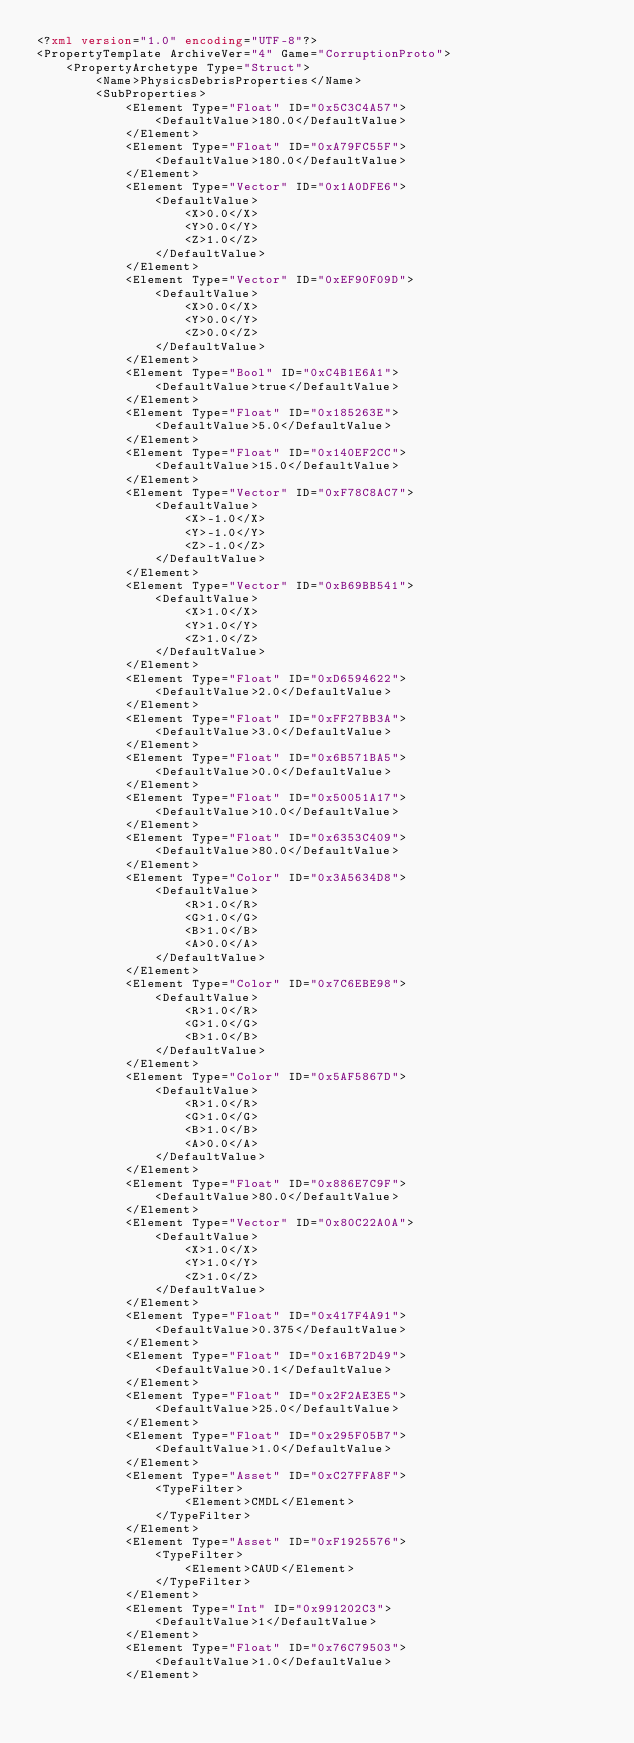Convert code to text. <code><loc_0><loc_0><loc_500><loc_500><_XML_><?xml version="1.0" encoding="UTF-8"?>
<PropertyTemplate ArchiveVer="4" Game="CorruptionProto">
    <PropertyArchetype Type="Struct">
        <Name>PhysicsDebrisProperties</Name>
        <SubProperties>
            <Element Type="Float" ID="0x5C3C4A57">
                <DefaultValue>180.0</DefaultValue>
            </Element>
            <Element Type="Float" ID="0xA79FC55F">
                <DefaultValue>180.0</DefaultValue>
            </Element>
            <Element Type="Vector" ID="0x1A0DFE6">
                <DefaultValue>
                    <X>0.0</X>
                    <Y>0.0</Y>
                    <Z>1.0</Z>
                </DefaultValue>
            </Element>
            <Element Type="Vector" ID="0xEF90F09D">
                <DefaultValue>
                    <X>0.0</X>
                    <Y>0.0</Y>
                    <Z>0.0</Z>
                </DefaultValue>
            </Element>
            <Element Type="Bool" ID="0xC4B1E6A1">
                <DefaultValue>true</DefaultValue>
            </Element>
            <Element Type="Float" ID="0x185263E">
                <DefaultValue>5.0</DefaultValue>
            </Element>
            <Element Type="Float" ID="0x140EF2CC">
                <DefaultValue>15.0</DefaultValue>
            </Element>
            <Element Type="Vector" ID="0xF78C8AC7">
                <DefaultValue>
                    <X>-1.0</X>
                    <Y>-1.0</Y>
                    <Z>-1.0</Z>
                </DefaultValue>
            </Element>
            <Element Type="Vector" ID="0xB69BB541">
                <DefaultValue>
                    <X>1.0</X>
                    <Y>1.0</Y>
                    <Z>1.0</Z>
                </DefaultValue>
            </Element>
            <Element Type="Float" ID="0xD6594622">
                <DefaultValue>2.0</DefaultValue>
            </Element>
            <Element Type="Float" ID="0xFF27BB3A">
                <DefaultValue>3.0</DefaultValue>
            </Element>
            <Element Type="Float" ID="0x6B571BA5">
                <DefaultValue>0.0</DefaultValue>
            </Element>
            <Element Type="Float" ID="0x50051A17">
                <DefaultValue>10.0</DefaultValue>
            </Element>
            <Element Type="Float" ID="0x6353C409">
                <DefaultValue>80.0</DefaultValue>
            </Element>
            <Element Type="Color" ID="0x3A5634D8">
                <DefaultValue>
                    <R>1.0</R>
                    <G>1.0</G>
                    <B>1.0</B>
                    <A>0.0</A>
                </DefaultValue>
            </Element>
            <Element Type="Color" ID="0x7C6EBE98">
                <DefaultValue>
                    <R>1.0</R>
                    <G>1.0</G>
                    <B>1.0</B>
                </DefaultValue>
            </Element>
            <Element Type="Color" ID="0x5AF5867D">
                <DefaultValue>
                    <R>1.0</R>
                    <G>1.0</G>
                    <B>1.0</B>
                    <A>0.0</A>
                </DefaultValue>
            </Element>
            <Element Type="Float" ID="0x886E7C9F">
                <DefaultValue>80.0</DefaultValue>
            </Element>
            <Element Type="Vector" ID="0x80C22A0A">
                <DefaultValue>
                    <X>1.0</X>
                    <Y>1.0</Y>
                    <Z>1.0</Z>
                </DefaultValue>
            </Element>
            <Element Type="Float" ID="0x417F4A91">
                <DefaultValue>0.375</DefaultValue>
            </Element>
            <Element Type="Float" ID="0x16B72D49">
                <DefaultValue>0.1</DefaultValue>
            </Element>
            <Element Type="Float" ID="0x2F2AE3E5">
                <DefaultValue>25.0</DefaultValue>
            </Element>
            <Element Type="Float" ID="0x295F05B7">
                <DefaultValue>1.0</DefaultValue>
            </Element>
            <Element Type="Asset" ID="0xC27FFA8F">
                <TypeFilter>
                    <Element>CMDL</Element>
                </TypeFilter>
            </Element>
            <Element Type="Asset" ID="0xF1925576">
                <TypeFilter>
                    <Element>CAUD</Element>
                </TypeFilter>
            </Element>
            <Element Type="Int" ID="0x991202C3">
                <DefaultValue>1</DefaultValue>
            </Element>
            <Element Type="Float" ID="0x76C79503">
                <DefaultValue>1.0</DefaultValue>
            </Element></code> 